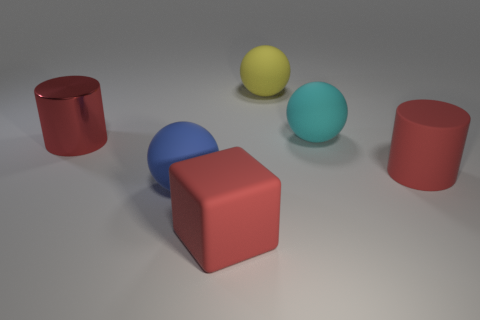Subtract all yellow blocks. Subtract all cyan cylinders. How many blocks are left? 1 Add 2 small blocks. How many objects exist? 8 Subtract all cylinders. How many objects are left? 4 Subtract 0 green balls. How many objects are left? 6 Subtract all cyan things. Subtract all big red metallic things. How many objects are left? 4 Add 4 large red metal cylinders. How many large red metal cylinders are left? 5 Add 5 red rubber cylinders. How many red rubber cylinders exist? 6 